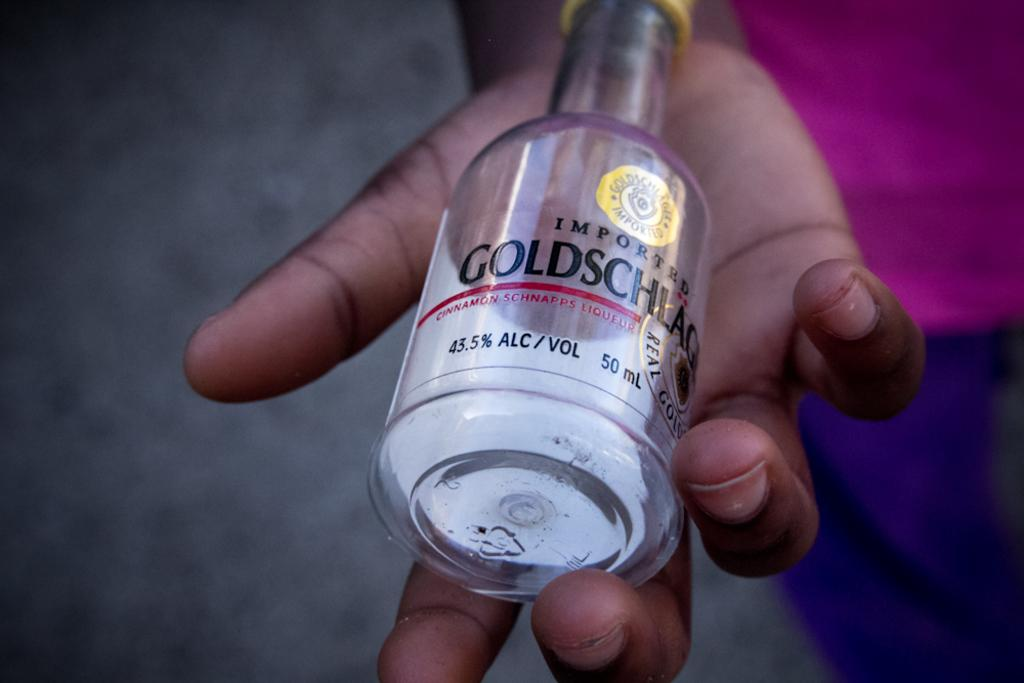What object can be seen in the image? There is a bottle in the image. Can you identify any specific details about the bottle? A brand name is written on the bottle. What is the bottle holding? The bottle is holding a person. How is the person dressed? The person is wearing a pink and violet color dress. How is the bottle used to measure the tax on the person's dress? The bottle is not used to measure tax on the person's dress; it is simply holding the person. Can you hear a whistle in the image? There is no whistle present in the image. 